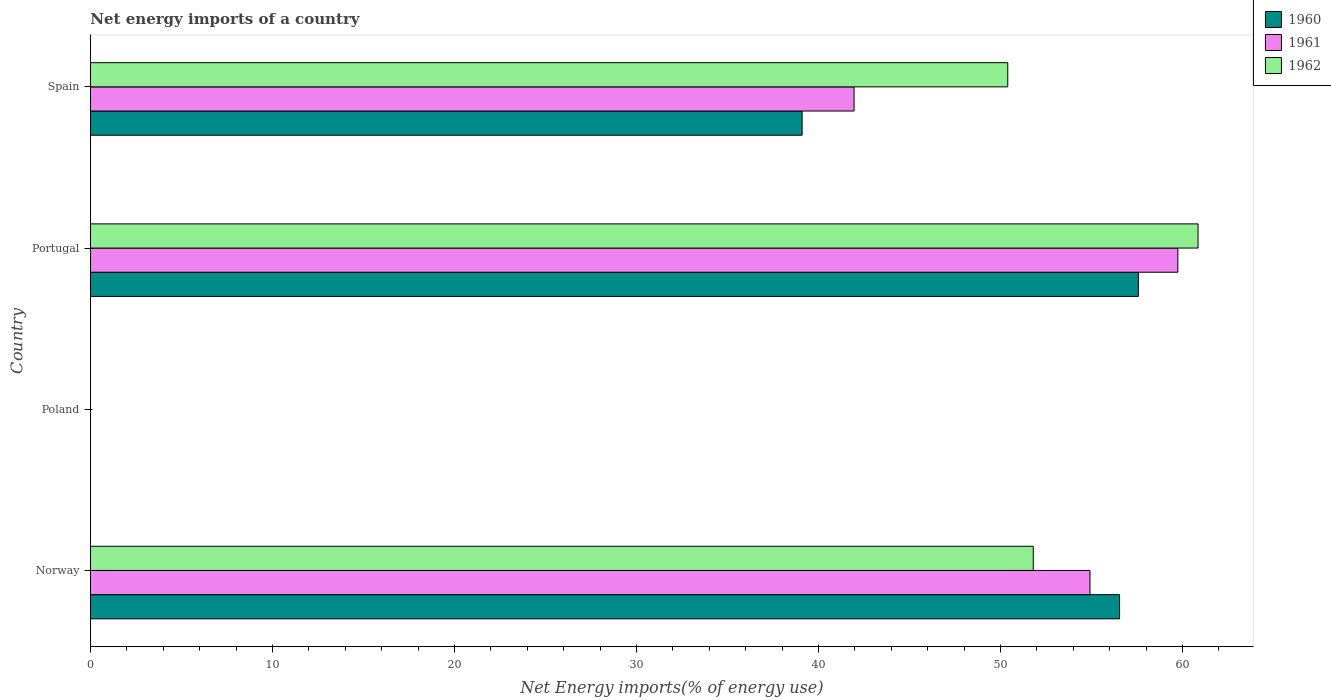How many different coloured bars are there?
Ensure brevity in your answer.  3. Are the number of bars per tick equal to the number of legend labels?
Ensure brevity in your answer.  No. Are the number of bars on each tick of the Y-axis equal?
Your answer should be very brief. No. What is the label of the 4th group of bars from the top?
Your answer should be very brief. Norway. What is the net energy imports in 1962 in Norway?
Keep it short and to the point. 51.8. Across all countries, what is the maximum net energy imports in 1962?
Keep it short and to the point. 60.85. Across all countries, what is the minimum net energy imports in 1960?
Keep it short and to the point. 0. What is the total net energy imports in 1962 in the graph?
Offer a terse response. 163.05. What is the difference between the net energy imports in 1962 in Norway and that in Portugal?
Your answer should be very brief. -9.05. What is the difference between the net energy imports in 1960 in Spain and the net energy imports in 1961 in Norway?
Provide a short and direct response. -15.82. What is the average net energy imports in 1960 per country?
Offer a terse response. 38.3. What is the difference between the net energy imports in 1961 and net energy imports in 1962 in Norway?
Offer a very short reply. 3.12. What is the ratio of the net energy imports in 1961 in Norway to that in Spain?
Your answer should be very brief. 1.31. Is the net energy imports in 1962 in Norway less than that in Portugal?
Ensure brevity in your answer.  Yes. What is the difference between the highest and the second highest net energy imports in 1960?
Your response must be concise. 1.03. What is the difference between the highest and the lowest net energy imports in 1960?
Your response must be concise. 57.57. In how many countries, is the net energy imports in 1961 greater than the average net energy imports in 1961 taken over all countries?
Your response must be concise. 3. Is it the case that in every country, the sum of the net energy imports in 1960 and net energy imports in 1962 is greater than the net energy imports in 1961?
Your response must be concise. No. Are all the bars in the graph horizontal?
Give a very brief answer. Yes. How many countries are there in the graph?
Your response must be concise. 4. What is the difference between two consecutive major ticks on the X-axis?
Offer a terse response. 10. Does the graph contain any zero values?
Provide a succinct answer. Yes. Where does the legend appear in the graph?
Keep it short and to the point. Top right. How are the legend labels stacked?
Ensure brevity in your answer.  Vertical. What is the title of the graph?
Your answer should be very brief. Net energy imports of a country. Does "1999" appear as one of the legend labels in the graph?
Ensure brevity in your answer.  No. What is the label or title of the X-axis?
Keep it short and to the point. Net Energy imports(% of energy use). What is the Net Energy imports(% of energy use) in 1960 in Norway?
Make the answer very short. 56.54. What is the Net Energy imports(% of energy use) in 1961 in Norway?
Give a very brief answer. 54.92. What is the Net Energy imports(% of energy use) of 1962 in Norway?
Your response must be concise. 51.8. What is the Net Energy imports(% of energy use) of 1962 in Poland?
Provide a succinct answer. 0. What is the Net Energy imports(% of energy use) of 1960 in Portugal?
Provide a short and direct response. 57.57. What is the Net Energy imports(% of energy use) of 1961 in Portugal?
Give a very brief answer. 59.74. What is the Net Energy imports(% of energy use) of 1962 in Portugal?
Offer a very short reply. 60.85. What is the Net Energy imports(% of energy use) of 1960 in Spain?
Make the answer very short. 39.1. What is the Net Energy imports(% of energy use) of 1961 in Spain?
Ensure brevity in your answer.  41.95. What is the Net Energy imports(% of energy use) in 1962 in Spain?
Keep it short and to the point. 50.4. Across all countries, what is the maximum Net Energy imports(% of energy use) of 1960?
Ensure brevity in your answer.  57.57. Across all countries, what is the maximum Net Energy imports(% of energy use) in 1961?
Give a very brief answer. 59.74. Across all countries, what is the maximum Net Energy imports(% of energy use) of 1962?
Make the answer very short. 60.85. Across all countries, what is the minimum Net Energy imports(% of energy use) in 1960?
Your response must be concise. 0. Across all countries, what is the minimum Net Energy imports(% of energy use) in 1962?
Give a very brief answer. 0. What is the total Net Energy imports(% of energy use) in 1960 in the graph?
Keep it short and to the point. 153.22. What is the total Net Energy imports(% of energy use) of 1961 in the graph?
Provide a short and direct response. 156.61. What is the total Net Energy imports(% of energy use) in 1962 in the graph?
Give a very brief answer. 163.05. What is the difference between the Net Energy imports(% of energy use) of 1960 in Norway and that in Portugal?
Your response must be concise. -1.03. What is the difference between the Net Energy imports(% of energy use) of 1961 in Norway and that in Portugal?
Make the answer very short. -4.83. What is the difference between the Net Energy imports(% of energy use) in 1962 in Norway and that in Portugal?
Provide a short and direct response. -9.05. What is the difference between the Net Energy imports(% of energy use) of 1960 in Norway and that in Spain?
Your response must be concise. 17.44. What is the difference between the Net Energy imports(% of energy use) of 1961 in Norway and that in Spain?
Provide a succinct answer. 12.96. What is the difference between the Net Energy imports(% of energy use) of 1962 in Norway and that in Spain?
Provide a short and direct response. 1.4. What is the difference between the Net Energy imports(% of energy use) of 1960 in Portugal and that in Spain?
Give a very brief answer. 18.47. What is the difference between the Net Energy imports(% of energy use) of 1961 in Portugal and that in Spain?
Provide a short and direct response. 17.79. What is the difference between the Net Energy imports(% of energy use) of 1962 in Portugal and that in Spain?
Provide a succinct answer. 10.46. What is the difference between the Net Energy imports(% of energy use) of 1960 in Norway and the Net Energy imports(% of energy use) of 1961 in Portugal?
Provide a succinct answer. -3.2. What is the difference between the Net Energy imports(% of energy use) in 1960 in Norway and the Net Energy imports(% of energy use) in 1962 in Portugal?
Make the answer very short. -4.31. What is the difference between the Net Energy imports(% of energy use) in 1961 in Norway and the Net Energy imports(% of energy use) in 1962 in Portugal?
Ensure brevity in your answer.  -5.94. What is the difference between the Net Energy imports(% of energy use) in 1960 in Norway and the Net Energy imports(% of energy use) in 1961 in Spain?
Keep it short and to the point. 14.59. What is the difference between the Net Energy imports(% of energy use) of 1960 in Norway and the Net Energy imports(% of energy use) of 1962 in Spain?
Make the answer very short. 6.14. What is the difference between the Net Energy imports(% of energy use) of 1961 in Norway and the Net Energy imports(% of energy use) of 1962 in Spain?
Keep it short and to the point. 4.52. What is the difference between the Net Energy imports(% of energy use) of 1960 in Portugal and the Net Energy imports(% of energy use) of 1961 in Spain?
Provide a short and direct response. 15.62. What is the difference between the Net Energy imports(% of energy use) in 1960 in Portugal and the Net Energy imports(% of energy use) in 1962 in Spain?
Your answer should be very brief. 7.18. What is the difference between the Net Energy imports(% of energy use) of 1961 in Portugal and the Net Energy imports(% of energy use) of 1962 in Spain?
Keep it short and to the point. 9.34. What is the average Net Energy imports(% of energy use) in 1960 per country?
Your answer should be compact. 38.3. What is the average Net Energy imports(% of energy use) of 1961 per country?
Keep it short and to the point. 39.15. What is the average Net Energy imports(% of energy use) in 1962 per country?
Offer a very short reply. 40.76. What is the difference between the Net Energy imports(% of energy use) of 1960 and Net Energy imports(% of energy use) of 1961 in Norway?
Provide a short and direct response. 1.62. What is the difference between the Net Energy imports(% of energy use) of 1960 and Net Energy imports(% of energy use) of 1962 in Norway?
Offer a very short reply. 4.74. What is the difference between the Net Energy imports(% of energy use) of 1961 and Net Energy imports(% of energy use) of 1962 in Norway?
Offer a very short reply. 3.12. What is the difference between the Net Energy imports(% of energy use) of 1960 and Net Energy imports(% of energy use) of 1961 in Portugal?
Offer a terse response. -2.17. What is the difference between the Net Energy imports(% of energy use) in 1960 and Net Energy imports(% of energy use) in 1962 in Portugal?
Keep it short and to the point. -3.28. What is the difference between the Net Energy imports(% of energy use) in 1961 and Net Energy imports(% of energy use) in 1962 in Portugal?
Offer a terse response. -1.11. What is the difference between the Net Energy imports(% of energy use) in 1960 and Net Energy imports(% of energy use) in 1961 in Spain?
Give a very brief answer. -2.85. What is the difference between the Net Energy imports(% of energy use) of 1960 and Net Energy imports(% of energy use) of 1962 in Spain?
Your response must be concise. -11.3. What is the difference between the Net Energy imports(% of energy use) of 1961 and Net Energy imports(% of energy use) of 1962 in Spain?
Your answer should be compact. -8.44. What is the ratio of the Net Energy imports(% of energy use) of 1960 in Norway to that in Portugal?
Ensure brevity in your answer.  0.98. What is the ratio of the Net Energy imports(% of energy use) in 1961 in Norway to that in Portugal?
Keep it short and to the point. 0.92. What is the ratio of the Net Energy imports(% of energy use) of 1962 in Norway to that in Portugal?
Ensure brevity in your answer.  0.85. What is the ratio of the Net Energy imports(% of energy use) in 1960 in Norway to that in Spain?
Offer a very short reply. 1.45. What is the ratio of the Net Energy imports(% of energy use) in 1961 in Norway to that in Spain?
Offer a terse response. 1.31. What is the ratio of the Net Energy imports(% of energy use) in 1962 in Norway to that in Spain?
Your answer should be compact. 1.03. What is the ratio of the Net Energy imports(% of energy use) of 1960 in Portugal to that in Spain?
Offer a very short reply. 1.47. What is the ratio of the Net Energy imports(% of energy use) of 1961 in Portugal to that in Spain?
Offer a terse response. 1.42. What is the ratio of the Net Energy imports(% of energy use) in 1962 in Portugal to that in Spain?
Your response must be concise. 1.21. What is the difference between the highest and the second highest Net Energy imports(% of energy use) of 1960?
Provide a short and direct response. 1.03. What is the difference between the highest and the second highest Net Energy imports(% of energy use) of 1961?
Offer a terse response. 4.83. What is the difference between the highest and the second highest Net Energy imports(% of energy use) in 1962?
Give a very brief answer. 9.05. What is the difference between the highest and the lowest Net Energy imports(% of energy use) of 1960?
Give a very brief answer. 57.57. What is the difference between the highest and the lowest Net Energy imports(% of energy use) of 1961?
Offer a terse response. 59.74. What is the difference between the highest and the lowest Net Energy imports(% of energy use) of 1962?
Offer a terse response. 60.85. 